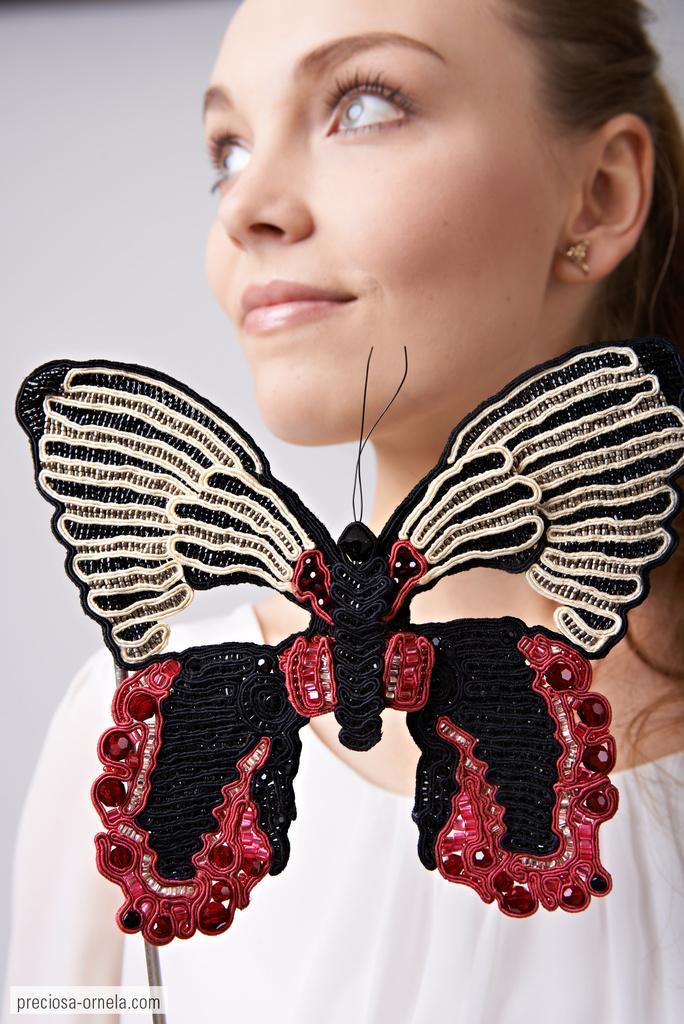Could you give a brief overview of what you see in this image? In this picture we can see a woman, in front of her we can find a butterfly toy. 